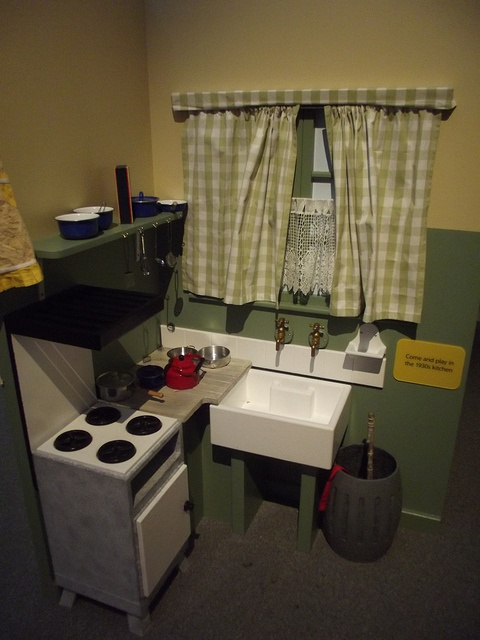Describe the objects in this image and their specific colors. I can see oven in black and gray tones, sink in black, lightgray, gray, darkgray, and beige tones, bowl in black tones, bowl in black, darkgray, gray, and tan tones, and bowl in black and gray tones in this image. 